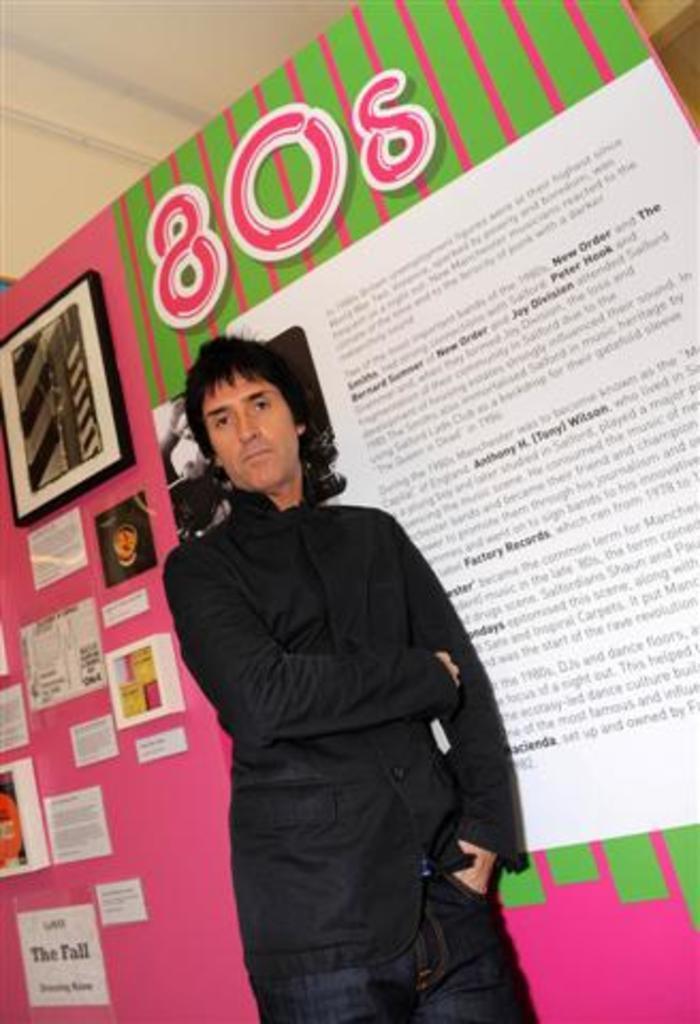Can you describe this image briefly? In this image I can see the person wearing the black color dress. To the side of the person I can see the papers, boards and frame attached to the pink and green color surface. 